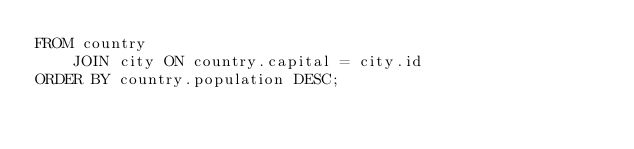Convert code to text. <code><loc_0><loc_0><loc_500><loc_500><_SQL_>FROM country
    JOIN city ON country.capital = city.id
ORDER BY country.population DESC;
</code> 